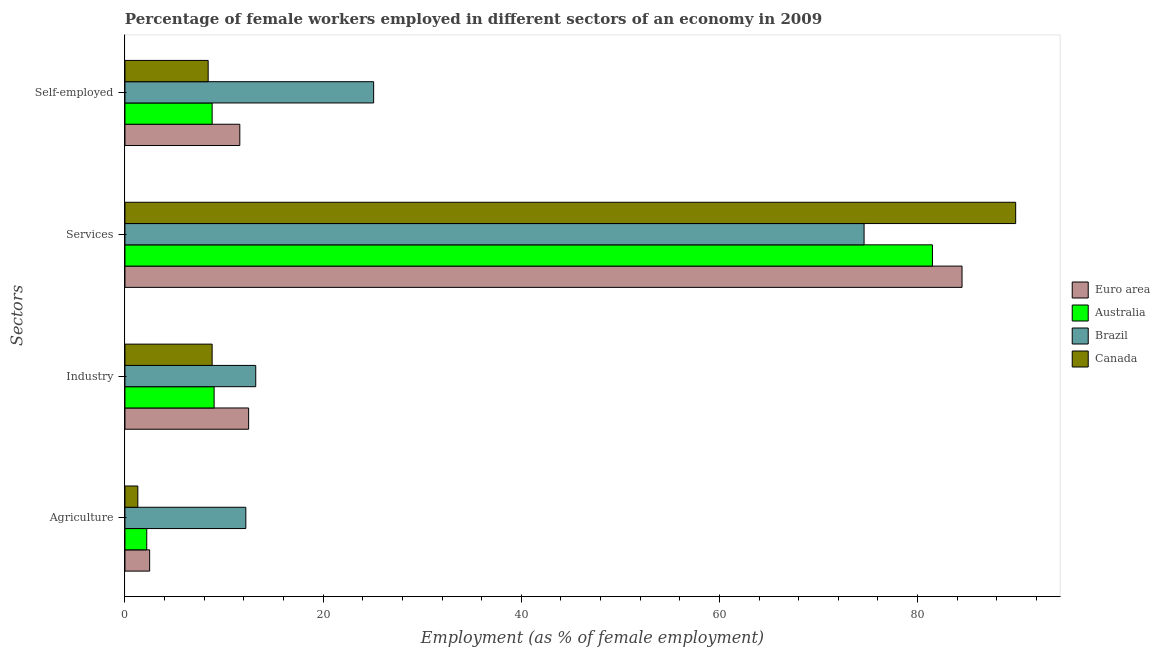How many bars are there on the 4th tick from the top?
Your answer should be compact. 4. How many bars are there on the 3rd tick from the bottom?
Keep it short and to the point. 4. What is the label of the 4th group of bars from the top?
Your answer should be very brief. Agriculture. What is the percentage of female workers in industry in Brazil?
Offer a very short reply. 13.2. Across all countries, what is the maximum percentage of self employed female workers?
Your response must be concise. 25.1. Across all countries, what is the minimum percentage of self employed female workers?
Make the answer very short. 8.4. In which country was the percentage of self employed female workers maximum?
Give a very brief answer. Brazil. In which country was the percentage of female workers in services minimum?
Your response must be concise. Brazil. What is the total percentage of female workers in services in the graph?
Your answer should be very brief. 330.49. What is the difference between the percentage of female workers in agriculture in Canada and that in Euro area?
Make the answer very short. -1.19. What is the difference between the percentage of female workers in services in Brazil and the percentage of female workers in industry in Canada?
Provide a short and direct response. 65.8. What is the average percentage of female workers in services per country?
Your answer should be compact. 82.62. What is the difference between the percentage of female workers in agriculture and percentage of female workers in industry in Australia?
Give a very brief answer. -6.8. What is the ratio of the percentage of female workers in agriculture in Canada to that in Australia?
Ensure brevity in your answer.  0.59. Is the difference between the percentage of self employed female workers in Canada and Australia greater than the difference between the percentage of female workers in services in Canada and Australia?
Your answer should be very brief. No. What is the difference between the highest and the second highest percentage of self employed female workers?
Offer a terse response. 13.51. What is the difference between the highest and the lowest percentage of self employed female workers?
Ensure brevity in your answer.  16.7. In how many countries, is the percentage of self employed female workers greater than the average percentage of self employed female workers taken over all countries?
Your answer should be very brief. 1. Is it the case that in every country, the sum of the percentage of female workers in industry and percentage of female workers in agriculture is greater than the sum of percentage of self employed female workers and percentage of female workers in services?
Give a very brief answer. No. What does the 4th bar from the top in Industry represents?
Keep it short and to the point. Euro area. What does the 1st bar from the bottom in Services represents?
Ensure brevity in your answer.  Euro area. Are all the bars in the graph horizontal?
Ensure brevity in your answer.  Yes. What is the difference between two consecutive major ticks on the X-axis?
Your answer should be very brief. 20. Where does the legend appear in the graph?
Give a very brief answer. Center right. How many legend labels are there?
Provide a short and direct response. 4. What is the title of the graph?
Keep it short and to the point. Percentage of female workers employed in different sectors of an economy in 2009. Does "St. Lucia" appear as one of the legend labels in the graph?
Your answer should be compact. No. What is the label or title of the X-axis?
Provide a succinct answer. Employment (as % of female employment). What is the label or title of the Y-axis?
Make the answer very short. Sectors. What is the Employment (as % of female employment) of Euro area in Agriculture?
Provide a short and direct response. 2.49. What is the Employment (as % of female employment) of Australia in Agriculture?
Offer a very short reply. 2.2. What is the Employment (as % of female employment) in Brazil in Agriculture?
Provide a short and direct response. 12.2. What is the Employment (as % of female employment) of Canada in Agriculture?
Your response must be concise. 1.3. What is the Employment (as % of female employment) of Euro area in Industry?
Offer a very short reply. 12.48. What is the Employment (as % of female employment) of Australia in Industry?
Give a very brief answer. 9. What is the Employment (as % of female employment) of Brazil in Industry?
Your response must be concise. 13.2. What is the Employment (as % of female employment) of Canada in Industry?
Your answer should be compact. 8.8. What is the Employment (as % of female employment) of Euro area in Services?
Offer a very short reply. 84.49. What is the Employment (as % of female employment) in Australia in Services?
Keep it short and to the point. 81.5. What is the Employment (as % of female employment) in Brazil in Services?
Your answer should be compact. 74.6. What is the Employment (as % of female employment) in Canada in Services?
Make the answer very short. 89.9. What is the Employment (as % of female employment) in Euro area in Self-employed?
Keep it short and to the point. 11.59. What is the Employment (as % of female employment) of Australia in Self-employed?
Keep it short and to the point. 8.8. What is the Employment (as % of female employment) in Brazil in Self-employed?
Offer a terse response. 25.1. What is the Employment (as % of female employment) in Canada in Self-employed?
Provide a short and direct response. 8.4. Across all Sectors, what is the maximum Employment (as % of female employment) in Euro area?
Ensure brevity in your answer.  84.49. Across all Sectors, what is the maximum Employment (as % of female employment) of Australia?
Your response must be concise. 81.5. Across all Sectors, what is the maximum Employment (as % of female employment) in Brazil?
Keep it short and to the point. 74.6. Across all Sectors, what is the maximum Employment (as % of female employment) in Canada?
Your answer should be compact. 89.9. Across all Sectors, what is the minimum Employment (as % of female employment) in Euro area?
Your response must be concise. 2.49. Across all Sectors, what is the minimum Employment (as % of female employment) in Australia?
Offer a very short reply. 2.2. Across all Sectors, what is the minimum Employment (as % of female employment) of Brazil?
Give a very brief answer. 12.2. Across all Sectors, what is the minimum Employment (as % of female employment) of Canada?
Keep it short and to the point. 1.3. What is the total Employment (as % of female employment) of Euro area in the graph?
Provide a succinct answer. 111.05. What is the total Employment (as % of female employment) in Australia in the graph?
Ensure brevity in your answer.  101.5. What is the total Employment (as % of female employment) of Brazil in the graph?
Give a very brief answer. 125.1. What is the total Employment (as % of female employment) in Canada in the graph?
Provide a short and direct response. 108.4. What is the difference between the Employment (as % of female employment) of Euro area in Agriculture and that in Industry?
Provide a succinct answer. -9.99. What is the difference between the Employment (as % of female employment) of Australia in Agriculture and that in Industry?
Make the answer very short. -6.8. What is the difference between the Employment (as % of female employment) in Brazil in Agriculture and that in Industry?
Give a very brief answer. -1. What is the difference between the Employment (as % of female employment) in Euro area in Agriculture and that in Services?
Provide a succinct answer. -81.99. What is the difference between the Employment (as % of female employment) of Australia in Agriculture and that in Services?
Make the answer very short. -79.3. What is the difference between the Employment (as % of female employment) in Brazil in Agriculture and that in Services?
Offer a very short reply. -62.4. What is the difference between the Employment (as % of female employment) in Canada in Agriculture and that in Services?
Provide a succinct answer. -88.6. What is the difference between the Employment (as % of female employment) in Euro area in Agriculture and that in Self-employed?
Your answer should be very brief. -9.1. What is the difference between the Employment (as % of female employment) in Australia in Agriculture and that in Self-employed?
Keep it short and to the point. -6.6. What is the difference between the Employment (as % of female employment) of Canada in Agriculture and that in Self-employed?
Give a very brief answer. -7.1. What is the difference between the Employment (as % of female employment) in Euro area in Industry and that in Services?
Give a very brief answer. -72. What is the difference between the Employment (as % of female employment) in Australia in Industry and that in Services?
Keep it short and to the point. -72.5. What is the difference between the Employment (as % of female employment) in Brazil in Industry and that in Services?
Provide a succinct answer. -61.4. What is the difference between the Employment (as % of female employment) in Canada in Industry and that in Services?
Provide a short and direct response. -81.1. What is the difference between the Employment (as % of female employment) in Euro area in Industry and that in Self-employed?
Make the answer very short. 0.89. What is the difference between the Employment (as % of female employment) of Australia in Industry and that in Self-employed?
Your response must be concise. 0.2. What is the difference between the Employment (as % of female employment) of Brazil in Industry and that in Self-employed?
Ensure brevity in your answer.  -11.9. What is the difference between the Employment (as % of female employment) in Euro area in Services and that in Self-employed?
Provide a short and direct response. 72.89. What is the difference between the Employment (as % of female employment) in Australia in Services and that in Self-employed?
Offer a very short reply. 72.7. What is the difference between the Employment (as % of female employment) in Brazil in Services and that in Self-employed?
Provide a short and direct response. 49.5. What is the difference between the Employment (as % of female employment) of Canada in Services and that in Self-employed?
Your answer should be very brief. 81.5. What is the difference between the Employment (as % of female employment) in Euro area in Agriculture and the Employment (as % of female employment) in Australia in Industry?
Offer a terse response. -6.51. What is the difference between the Employment (as % of female employment) of Euro area in Agriculture and the Employment (as % of female employment) of Brazil in Industry?
Keep it short and to the point. -10.71. What is the difference between the Employment (as % of female employment) of Euro area in Agriculture and the Employment (as % of female employment) of Canada in Industry?
Your response must be concise. -6.31. What is the difference between the Employment (as % of female employment) of Australia in Agriculture and the Employment (as % of female employment) of Canada in Industry?
Provide a succinct answer. -6.6. What is the difference between the Employment (as % of female employment) of Euro area in Agriculture and the Employment (as % of female employment) of Australia in Services?
Offer a very short reply. -79.01. What is the difference between the Employment (as % of female employment) in Euro area in Agriculture and the Employment (as % of female employment) in Brazil in Services?
Offer a very short reply. -72.11. What is the difference between the Employment (as % of female employment) of Euro area in Agriculture and the Employment (as % of female employment) of Canada in Services?
Your answer should be very brief. -87.41. What is the difference between the Employment (as % of female employment) of Australia in Agriculture and the Employment (as % of female employment) of Brazil in Services?
Your answer should be very brief. -72.4. What is the difference between the Employment (as % of female employment) of Australia in Agriculture and the Employment (as % of female employment) of Canada in Services?
Offer a very short reply. -87.7. What is the difference between the Employment (as % of female employment) of Brazil in Agriculture and the Employment (as % of female employment) of Canada in Services?
Your answer should be very brief. -77.7. What is the difference between the Employment (as % of female employment) of Euro area in Agriculture and the Employment (as % of female employment) of Australia in Self-employed?
Your answer should be compact. -6.31. What is the difference between the Employment (as % of female employment) in Euro area in Agriculture and the Employment (as % of female employment) in Brazil in Self-employed?
Your answer should be very brief. -22.61. What is the difference between the Employment (as % of female employment) of Euro area in Agriculture and the Employment (as % of female employment) of Canada in Self-employed?
Your response must be concise. -5.91. What is the difference between the Employment (as % of female employment) of Australia in Agriculture and the Employment (as % of female employment) of Brazil in Self-employed?
Provide a short and direct response. -22.9. What is the difference between the Employment (as % of female employment) of Euro area in Industry and the Employment (as % of female employment) of Australia in Services?
Offer a terse response. -69.02. What is the difference between the Employment (as % of female employment) of Euro area in Industry and the Employment (as % of female employment) of Brazil in Services?
Provide a succinct answer. -62.12. What is the difference between the Employment (as % of female employment) of Euro area in Industry and the Employment (as % of female employment) of Canada in Services?
Give a very brief answer. -77.42. What is the difference between the Employment (as % of female employment) of Australia in Industry and the Employment (as % of female employment) of Brazil in Services?
Ensure brevity in your answer.  -65.6. What is the difference between the Employment (as % of female employment) of Australia in Industry and the Employment (as % of female employment) of Canada in Services?
Offer a terse response. -80.9. What is the difference between the Employment (as % of female employment) in Brazil in Industry and the Employment (as % of female employment) in Canada in Services?
Your response must be concise. -76.7. What is the difference between the Employment (as % of female employment) in Euro area in Industry and the Employment (as % of female employment) in Australia in Self-employed?
Your answer should be compact. 3.68. What is the difference between the Employment (as % of female employment) in Euro area in Industry and the Employment (as % of female employment) in Brazil in Self-employed?
Offer a very short reply. -12.62. What is the difference between the Employment (as % of female employment) of Euro area in Industry and the Employment (as % of female employment) of Canada in Self-employed?
Keep it short and to the point. 4.08. What is the difference between the Employment (as % of female employment) in Australia in Industry and the Employment (as % of female employment) in Brazil in Self-employed?
Your answer should be very brief. -16.1. What is the difference between the Employment (as % of female employment) of Australia in Industry and the Employment (as % of female employment) of Canada in Self-employed?
Keep it short and to the point. 0.6. What is the difference between the Employment (as % of female employment) of Euro area in Services and the Employment (as % of female employment) of Australia in Self-employed?
Your answer should be compact. 75.69. What is the difference between the Employment (as % of female employment) in Euro area in Services and the Employment (as % of female employment) in Brazil in Self-employed?
Offer a terse response. 59.39. What is the difference between the Employment (as % of female employment) in Euro area in Services and the Employment (as % of female employment) in Canada in Self-employed?
Offer a terse response. 76.09. What is the difference between the Employment (as % of female employment) of Australia in Services and the Employment (as % of female employment) of Brazil in Self-employed?
Offer a very short reply. 56.4. What is the difference between the Employment (as % of female employment) of Australia in Services and the Employment (as % of female employment) of Canada in Self-employed?
Give a very brief answer. 73.1. What is the difference between the Employment (as % of female employment) in Brazil in Services and the Employment (as % of female employment) in Canada in Self-employed?
Provide a short and direct response. 66.2. What is the average Employment (as % of female employment) in Euro area per Sectors?
Offer a terse response. 27.76. What is the average Employment (as % of female employment) of Australia per Sectors?
Offer a terse response. 25.38. What is the average Employment (as % of female employment) in Brazil per Sectors?
Your answer should be very brief. 31.27. What is the average Employment (as % of female employment) of Canada per Sectors?
Your response must be concise. 27.1. What is the difference between the Employment (as % of female employment) of Euro area and Employment (as % of female employment) of Australia in Agriculture?
Offer a very short reply. 0.29. What is the difference between the Employment (as % of female employment) of Euro area and Employment (as % of female employment) of Brazil in Agriculture?
Offer a terse response. -9.71. What is the difference between the Employment (as % of female employment) in Euro area and Employment (as % of female employment) in Canada in Agriculture?
Your response must be concise. 1.19. What is the difference between the Employment (as % of female employment) in Australia and Employment (as % of female employment) in Brazil in Agriculture?
Your answer should be compact. -10. What is the difference between the Employment (as % of female employment) of Australia and Employment (as % of female employment) of Canada in Agriculture?
Ensure brevity in your answer.  0.9. What is the difference between the Employment (as % of female employment) of Brazil and Employment (as % of female employment) of Canada in Agriculture?
Your response must be concise. 10.9. What is the difference between the Employment (as % of female employment) in Euro area and Employment (as % of female employment) in Australia in Industry?
Give a very brief answer. 3.48. What is the difference between the Employment (as % of female employment) in Euro area and Employment (as % of female employment) in Brazil in Industry?
Provide a short and direct response. -0.72. What is the difference between the Employment (as % of female employment) in Euro area and Employment (as % of female employment) in Canada in Industry?
Offer a terse response. 3.68. What is the difference between the Employment (as % of female employment) of Australia and Employment (as % of female employment) of Brazil in Industry?
Your answer should be very brief. -4.2. What is the difference between the Employment (as % of female employment) of Euro area and Employment (as % of female employment) of Australia in Services?
Keep it short and to the point. 2.99. What is the difference between the Employment (as % of female employment) in Euro area and Employment (as % of female employment) in Brazil in Services?
Give a very brief answer. 9.89. What is the difference between the Employment (as % of female employment) in Euro area and Employment (as % of female employment) in Canada in Services?
Keep it short and to the point. -5.41. What is the difference between the Employment (as % of female employment) in Australia and Employment (as % of female employment) in Canada in Services?
Ensure brevity in your answer.  -8.4. What is the difference between the Employment (as % of female employment) of Brazil and Employment (as % of female employment) of Canada in Services?
Your answer should be compact. -15.3. What is the difference between the Employment (as % of female employment) of Euro area and Employment (as % of female employment) of Australia in Self-employed?
Give a very brief answer. 2.79. What is the difference between the Employment (as % of female employment) of Euro area and Employment (as % of female employment) of Brazil in Self-employed?
Provide a succinct answer. -13.51. What is the difference between the Employment (as % of female employment) in Euro area and Employment (as % of female employment) in Canada in Self-employed?
Your answer should be compact. 3.19. What is the difference between the Employment (as % of female employment) of Australia and Employment (as % of female employment) of Brazil in Self-employed?
Give a very brief answer. -16.3. What is the difference between the Employment (as % of female employment) in Australia and Employment (as % of female employment) in Canada in Self-employed?
Keep it short and to the point. 0.4. What is the ratio of the Employment (as % of female employment) in Euro area in Agriculture to that in Industry?
Provide a short and direct response. 0.2. What is the ratio of the Employment (as % of female employment) in Australia in Agriculture to that in Industry?
Provide a succinct answer. 0.24. What is the ratio of the Employment (as % of female employment) in Brazil in Agriculture to that in Industry?
Keep it short and to the point. 0.92. What is the ratio of the Employment (as % of female employment) in Canada in Agriculture to that in Industry?
Your answer should be very brief. 0.15. What is the ratio of the Employment (as % of female employment) of Euro area in Agriculture to that in Services?
Keep it short and to the point. 0.03. What is the ratio of the Employment (as % of female employment) of Australia in Agriculture to that in Services?
Give a very brief answer. 0.03. What is the ratio of the Employment (as % of female employment) in Brazil in Agriculture to that in Services?
Offer a very short reply. 0.16. What is the ratio of the Employment (as % of female employment) in Canada in Agriculture to that in Services?
Your answer should be compact. 0.01. What is the ratio of the Employment (as % of female employment) in Euro area in Agriculture to that in Self-employed?
Make the answer very short. 0.21. What is the ratio of the Employment (as % of female employment) in Australia in Agriculture to that in Self-employed?
Your response must be concise. 0.25. What is the ratio of the Employment (as % of female employment) in Brazil in Agriculture to that in Self-employed?
Give a very brief answer. 0.49. What is the ratio of the Employment (as % of female employment) of Canada in Agriculture to that in Self-employed?
Offer a terse response. 0.15. What is the ratio of the Employment (as % of female employment) of Euro area in Industry to that in Services?
Your answer should be compact. 0.15. What is the ratio of the Employment (as % of female employment) in Australia in Industry to that in Services?
Ensure brevity in your answer.  0.11. What is the ratio of the Employment (as % of female employment) in Brazil in Industry to that in Services?
Give a very brief answer. 0.18. What is the ratio of the Employment (as % of female employment) of Canada in Industry to that in Services?
Provide a succinct answer. 0.1. What is the ratio of the Employment (as % of female employment) of Euro area in Industry to that in Self-employed?
Your response must be concise. 1.08. What is the ratio of the Employment (as % of female employment) in Australia in Industry to that in Self-employed?
Your response must be concise. 1.02. What is the ratio of the Employment (as % of female employment) in Brazil in Industry to that in Self-employed?
Provide a succinct answer. 0.53. What is the ratio of the Employment (as % of female employment) of Canada in Industry to that in Self-employed?
Your answer should be compact. 1.05. What is the ratio of the Employment (as % of female employment) in Euro area in Services to that in Self-employed?
Offer a very short reply. 7.29. What is the ratio of the Employment (as % of female employment) in Australia in Services to that in Self-employed?
Offer a terse response. 9.26. What is the ratio of the Employment (as % of female employment) of Brazil in Services to that in Self-employed?
Offer a terse response. 2.97. What is the ratio of the Employment (as % of female employment) in Canada in Services to that in Self-employed?
Offer a terse response. 10.7. What is the difference between the highest and the second highest Employment (as % of female employment) of Euro area?
Your answer should be compact. 72. What is the difference between the highest and the second highest Employment (as % of female employment) in Australia?
Make the answer very short. 72.5. What is the difference between the highest and the second highest Employment (as % of female employment) of Brazil?
Your answer should be compact. 49.5. What is the difference between the highest and the second highest Employment (as % of female employment) in Canada?
Make the answer very short. 81.1. What is the difference between the highest and the lowest Employment (as % of female employment) of Euro area?
Give a very brief answer. 81.99. What is the difference between the highest and the lowest Employment (as % of female employment) in Australia?
Ensure brevity in your answer.  79.3. What is the difference between the highest and the lowest Employment (as % of female employment) in Brazil?
Offer a terse response. 62.4. What is the difference between the highest and the lowest Employment (as % of female employment) in Canada?
Keep it short and to the point. 88.6. 